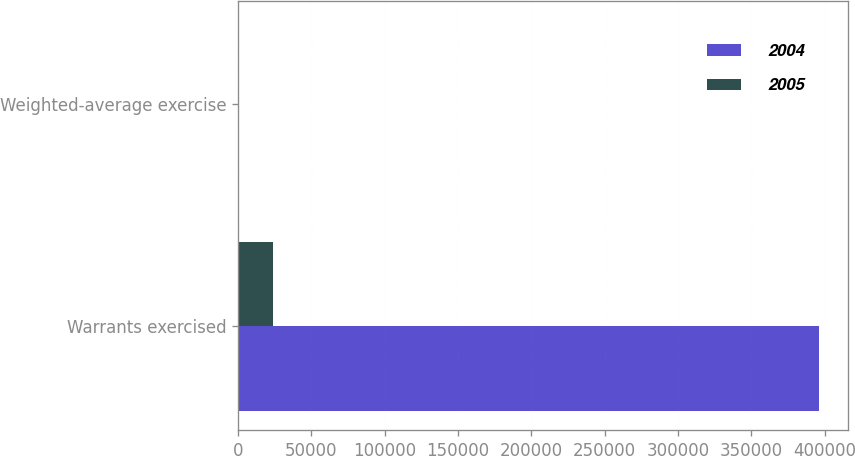Convert chart to OTSL. <chart><loc_0><loc_0><loc_500><loc_500><stacked_bar_chart><ecel><fcel>Warrants exercised<fcel>Weighted-average exercise<nl><fcel>2004<fcel>395908<fcel>20.22<nl><fcel>2005<fcel>23667<fcel>15.3<nl></chart> 